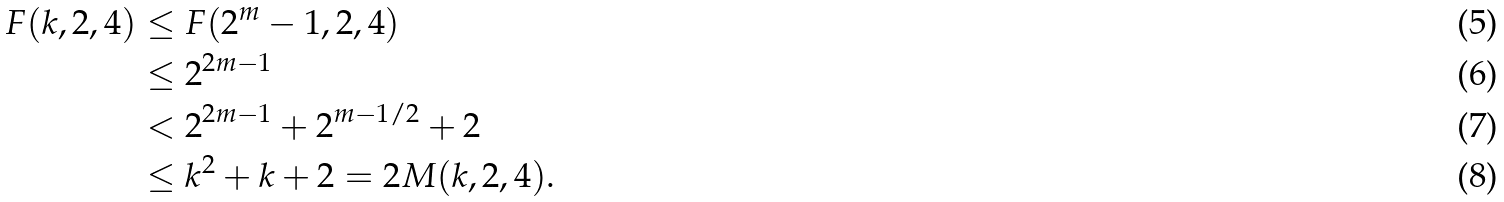Convert formula to latex. <formula><loc_0><loc_0><loc_500><loc_500>F ( k , 2 , 4 ) & \leq F ( 2 ^ { m } - 1 , 2 , 4 ) \\ & \leq 2 ^ { 2 m - 1 } \\ & < 2 ^ { 2 m - 1 } + 2 ^ { m - 1 / 2 } + 2 \\ & \leq k ^ { 2 } + k + 2 = 2 M ( k , 2 , 4 ) .</formula> 